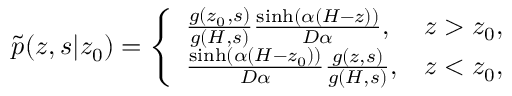Convert formula to latex. <formula><loc_0><loc_0><loc_500><loc_500>\begin{array} { r } { \tilde { p } ( z , s | z _ { 0 } ) = \left \{ \begin{array} { l l } { \frac { g ( z _ { 0 } , s ) } { g ( H , s ) } \frac { \sinh ( \alpha ( H - z ) ) } { D \alpha } , } & { z > z _ { 0 } , } \\ { \frac { \sinh \left ( \alpha \left ( H - z _ { 0 } \right ) \right ) } { D \alpha } \frac { g ( z , s ) } { g ( H , s ) } , } & { z < z _ { 0 } , } \end{array} } \end{array}</formula> 